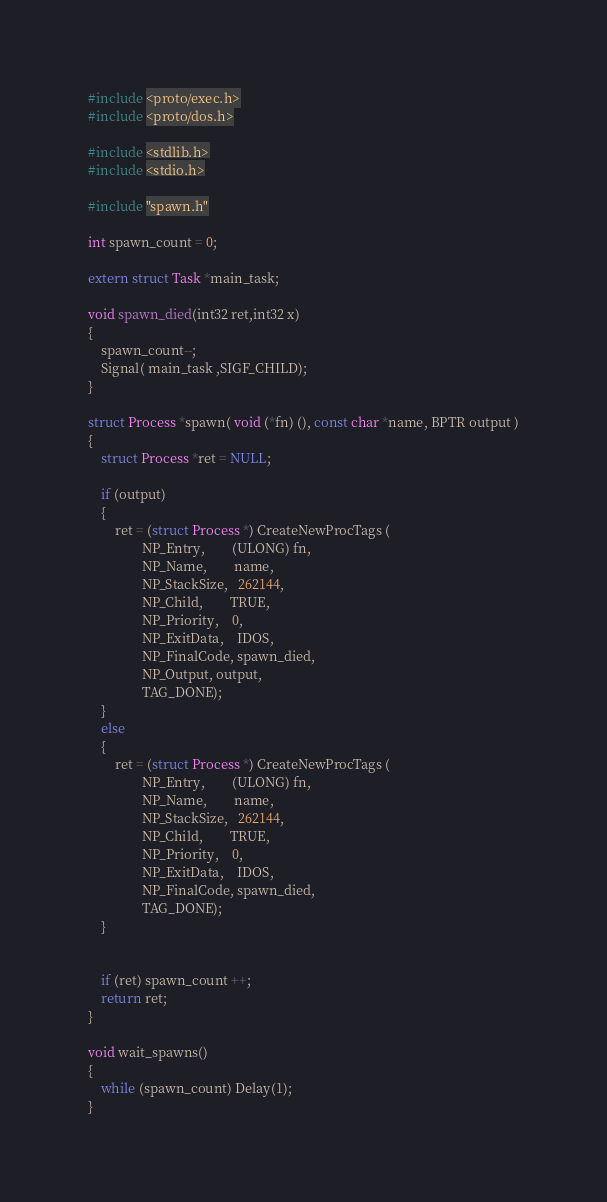Convert code to text. <code><loc_0><loc_0><loc_500><loc_500><_C++_>
#include <proto/exec.h>
#include <proto/dos.h>

#include <stdlib.h>
#include <stdio.h>

#include "spawn.h"

int spawn_count = 0;

extern struct Task *main_task;

void spawn_died(int32 ret,int32 x)
{
	spawn_count--;
	Signal( main_task ,SIGF_CHILD);
}

struct Process *spawn( void (*fn) (), const char *name, BPTR output )
{
	struct Process *ret = NULL;

	if (output)
	{
		ret = (struct Process *) CreateNewProcTags (
	   			NP_Entry, 		(ULONG) fn,
				NP_Name,	   	name,
				NP_StackSize,   262144,
				NP_Child,		TRUE,
				NP_Priority,	0,
				NP_ExitData, 	IDOS,
				NP_FinalCode, spawn_died,
				NP_Output, output,
				TAG_DONE);
	}
	else
	{
		ret = (struct Process *) CreateNewProcTags (
	   			NP_Entry, 		(ULONG) fn,
				NP_Name,	   	name,
				NP_StackSize,   262144,
				NP_Child,		TRUE,
				NP_Priority,	0,
				NP_ExitData, 	IDOS,
				NP_FinalCode, spawn_died,
				TAG_DONE);
	}


	if (ret) spawn_count ++;
	return ret;
}

void wait_spawns()
{
	while (spawn_count) Delay(1);
}
</code> 